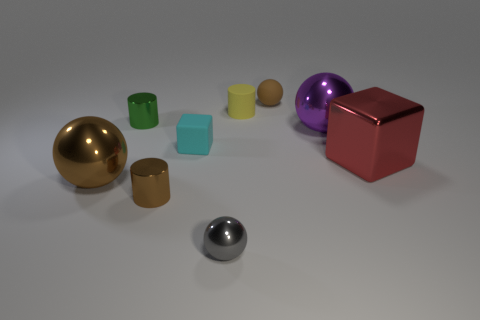Add 1 big blue balls. How many objects exist? 10 Subtract all cylinders. How many objects are left? 6 Add 8 tiny green metal cylinders. How many tiny green metal cylinders are left? 9 Add 6 tiny cyan metallic balls. How many tiny cyan metallic balls exist? 6 Subtract 1 red blocks. How many objects are left? 8 Subtract all small brown spheres. Subtract all yellow matte cylinders. How many objects are left? 7 